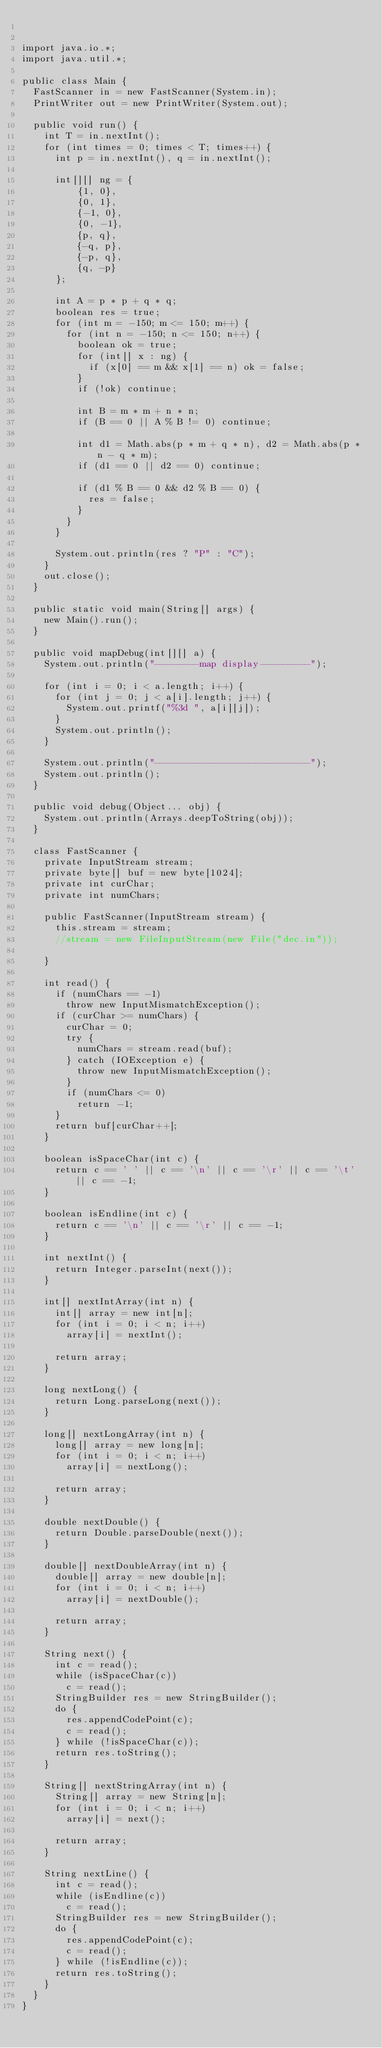<code> <loc_0><loc_0><loc_500><loc_500><_Java_>

import java.io.*;
import java.util.*;

public class Main {
	FastScanner in = new FastScanner(System.in);
	PrintWriter out = new PrintWriter(System.out);
	
	public void run() {
		int T = in.nextInt();
		for (int times = 0; times < T; times++) {
			int p = in.nextInt(), q = in.nextInt();
			
			int[][] ng = {
					{1, 0},
					{0, 1},
					{-1, 0},
					{0, -1},
					{p, q},
					{-q, p},
					{-p, q},
					{q, -p}
			};
			
			int A = p * p + q * q;
			boolean res = true;
			for (int m = -150; m <= 150; m++) {
				for (int n = -150; n <= 150; n++) {
					boolean ok = true;
					for (int[] x : ng) {
						if (x[0] == m && x[1] == n) ok = false;
					}
					if (!ok) continue;
					
					int B = m * m + n * n;
					if (B == 0 || A % B != 0) continue;
					
					int d1 = Math.abs(p * m + q * n), d2 = Math.abs(p * n - q * m);
					if (d1 == 0 || d2 == 0) continue;

					if (d1 % B == 0 && d2 % B == 0) {
						res = false;
					}
				}
			}
			
			System.out.println(res ? "P" : "C");
		}
		out.close();
	}

	public static void main(String[] args) {
		new Main().run();
	}

	public void mapDebug(int[][] a) {
		System.out.println("--------map display---------");

		for (int i = 0; i < a.length; i++) {
			for (int j = 0; j < a[i].length; j++) {
				System.out.printf("%3d ", a[i][j]);
			}
			System.out.println();
		}

		System.out.println("----------------------------");
		System.out.println();
	}

	public void debug(Object... obj) {
		System.out.println(Arrays.deepToString(obj));
	}

	class FastScanner {
		private InputStream stream;
		private byte[] buf = new byte[1024];
		private int curChar;
		private int numChars;

		public FastScanner(InputStream stream) {
			this.stream = stream;
			//stream = new FileInputStream(new File("dec.in"));

		}

		int read() {
			if (numChars == -1)
				throw new InputMismatchException();
			if (curChar >= numChars) {
				curChar = 0;
				try {
					numChars = stream.read(buf);
				} catch (IOException e) {
					throw new InputMismatchException();
				}
				if (numChars <= 0)
					return -1;
			}
			return buf[curChar++];
		}

		boolean isSpaceChar(int c) {
			return c == ' ' || c == '\n' || c == '\r' || c == '\t' || c == -1;
		}

		boolean isEndline(int c) {
			return c == '\n' || c == '\r' || c == -1;
		}

		int nextInt() {
			return Integer.parseInt(next());
		}

		int[] nextIntArray(int n) {
			int[] array = new int[n];
			for (int i = 0; i < n; i++)
				array[i] = nextInt();

			return array;
		}

		long nextLong() {
			return Long.parseLong(next());
		}

		long[] nextLongArray(int n) {
			long[] array = new long[n];
			for (int i = 0; i < n; i++)
				array[i] = nextLong();

			return array;
		}

		double nextDouble() {
			return Double.parseDouble(next());
		}

		double[] nextDoubleArray(int n) {
			double[] array = new double[n];
			for (int i = 0; i < n; i++)
				array[i] = nextDouble();

			return array;
		}

		String next() {
			int c = read();
			while (isSpaceChar(c))
				c = read();
			StringBuilder res = new StringBuilder();
			do {
				res.appendCodePoint(c);
				c = read();
			} while (!isSpaceChar(c));
			return res.toString();
		}

		String[] nextStringArray(int n) {
			String[] array = new String[n];
			for (int i = 0; i < n; i++)
				array[i] = next();

			return array;
		}

		String nextLine() {
			int c = read();
			while (isEndline(c))
				c = read();
			StringBuilder res = new StringBuilder();
			do {
				res.appendCodePoint(c);
				c = read();
			} while (!isEndline(c));
			return res.toString();
		}
	}
}</code> 